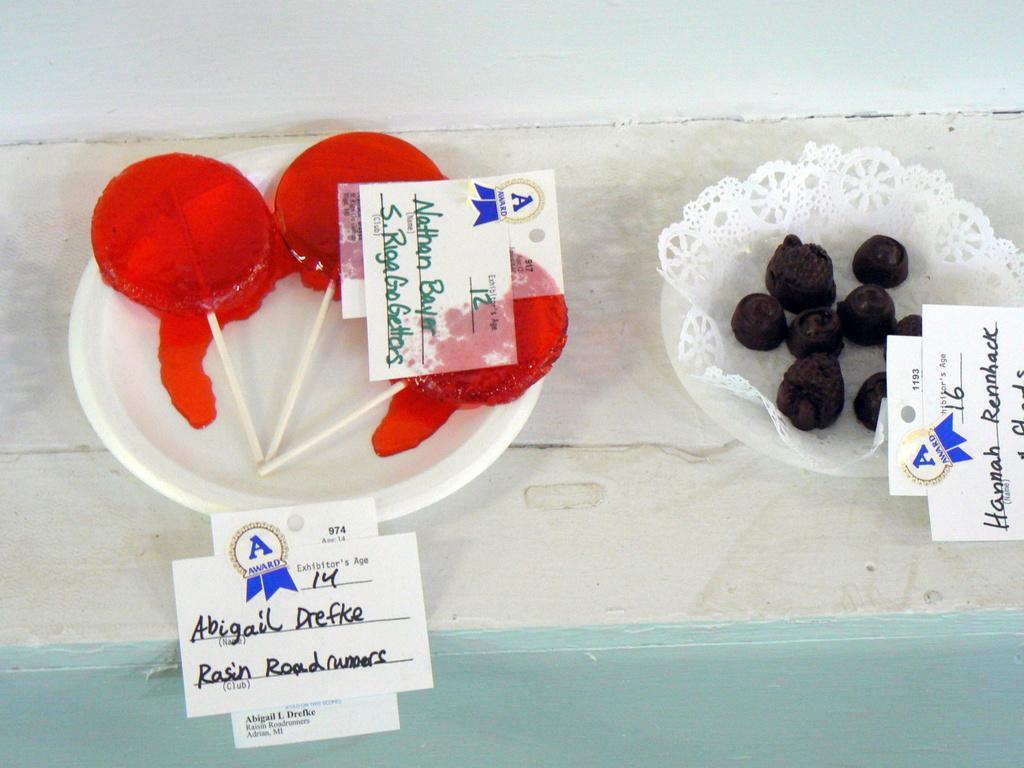In one or two sentences, can you explain what this image depicts? In this picture we can see candies and papers in the plate. On the right side of the image, there is food, a cloth and a paper in the plate. At the top of the image, it looks like a wall. 